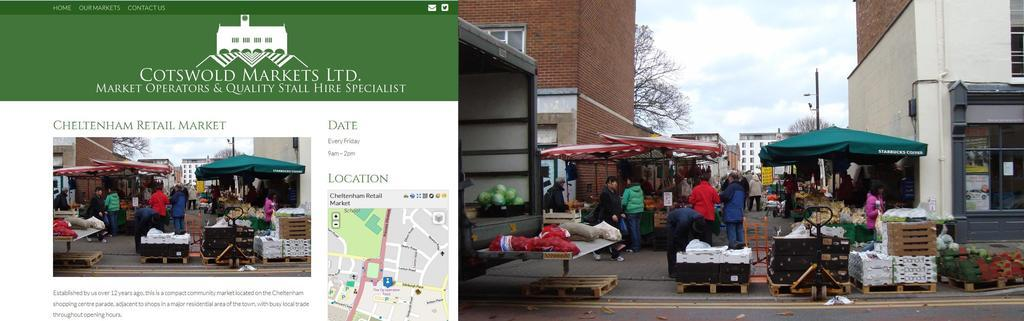What is happening on the right side of the image? There are people in the market on the right side of the image. What is the weather like in the market? The sky is sunny in the market. What type of bomb can be seen in the image? There is no bomb present in the image; it features people in a market with a sunny sky. 